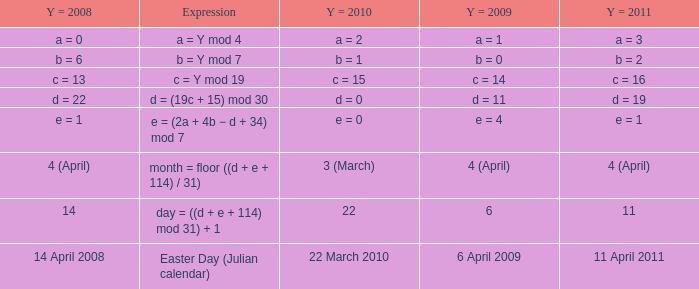What is the y = 2008 when y = 2011 is a = 3? A = 0. 